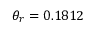<formula> <loc_0><loc_0><loc_500><loc_500>\theta _ { r } = 0 . 1 8 1 2</formula> 